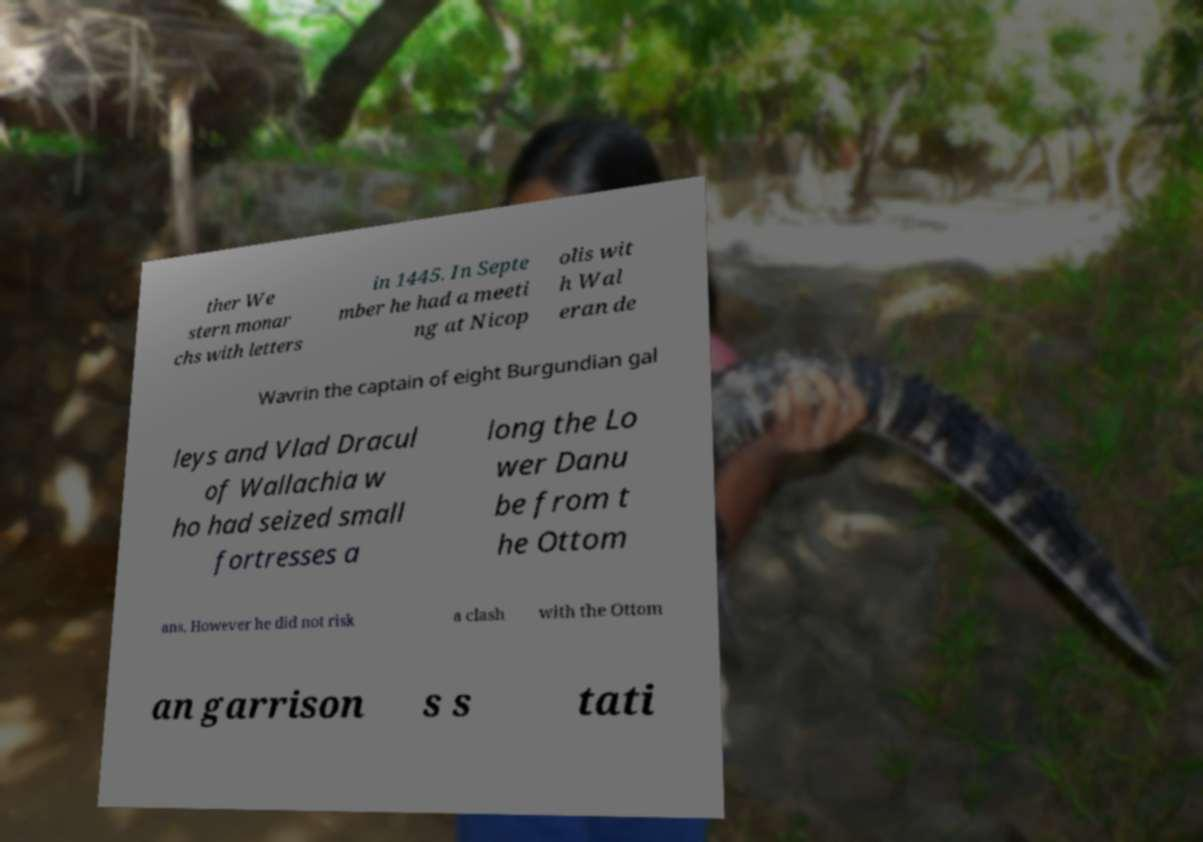What messages or text are displayed in this image? I need them in a readable, typed format. ther We stern monar chs with letters in 1445. In Septe mber he had a meeti ng at Nicop olis wit h Wal eran de Wavrin the captain of eight Burgundian gal leys and Vlad Dracul of Wallachia w ho had seized small fortresses a long the Lo wer Danu be from t he Ottom ans. However he did not risk a clash with the Ottom an garrison s s tati 